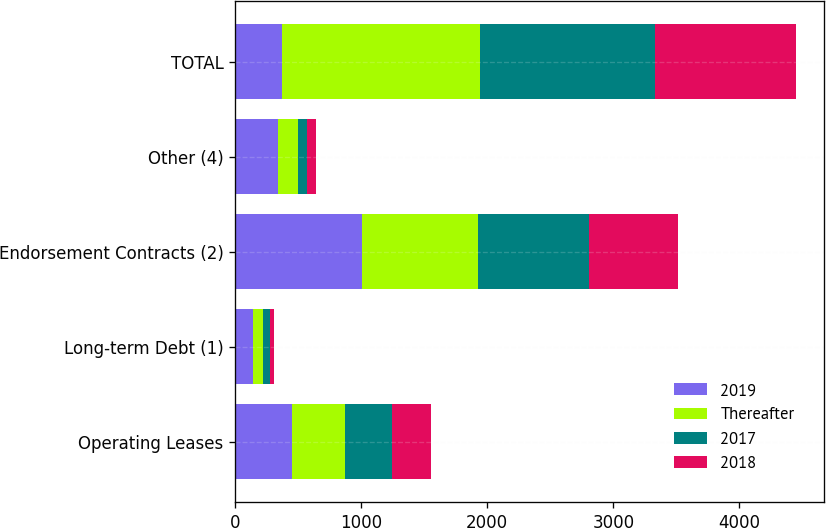<chart> <loc_0><loc_0><loc_500><loc_500><stacked_bar_chart><ecel><fcel>Operating Leases<fcel>Long-term Debt (1)<fcel>Endorsement Contracts (2)<fcel>Other (4)<fcel>TOTAL<nl><fcel>2019<fcel>447<fcel>142<fcel>1009<fcel>343<fcel>371<nl><fcel>Thereafter<fcel>423<fcel>77<fcel>919<fcel>152<fcel>1573<nl><fcel>2017<fcel>371<fcel>55<fcel>882<fcel>75<fcel>1384<nl><fcel>2018<fcel>311<fcel>36<fcel>706<fcel>72<fcel>1125<nl></chart> 